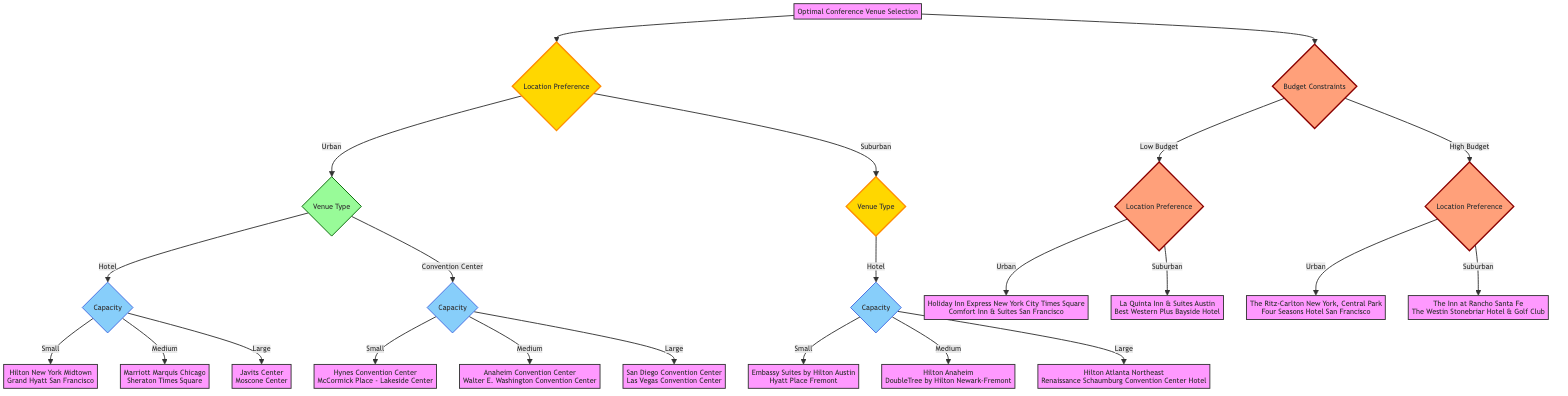What are the two possible categories for Location Preference? The diagram shows two main branches under the Location Preference node: Urban and Suburban.
Answer: Urban and Suburban Which venues are listed for a Small Hotel in an Urban location? The diagram points to the Hotel node under Urban and then specifies Small capacity, leading to the venues Hilton New York Midtown and Grand Hyatt San Francisco.
Answer: Hilton New York Midtown, Grand Hyatt San Francisco How many venues are available for Medium Capacity in Convention Centers? The diagram indicates a Medium capacity node under the Convention Center type, with two venues listed: Anaheim Convention Center and Walter E. Washington Convention Center, totaling two venues.
Answer: 2 If an attendee has a Low Budget, which two Urban venues can they select? The diagram branches from the Low Budget node to the Urban location, which lists Holiday Inn Express New York City Times Square and Comfort Inn & Suites San Francisco as available venues.
Answer: Holiday Inn Express New York City Times Square, Comfort Inn & Suites San Francisco What is the next criterion after selecting Suburban for Low Budget? Following the selection of Suburban under the Low Budget, the next criterion is Location Preference, which then branches to different venues based on the Low Budget selection.
Answer: Venue Preference Which type of venue has the highest capacity options listed? By examining the diagram, the Convention Center type offers venues categorized as Small (<150 attendees), Medium (150-500 attendees), and Large (>500 attendees), indicating it has three capacity options, which is more than the Hotel type.
Answer: Convention Center Which two venues are suitable for a High Budget in Suburban areas? The High Budget node leads to Suburban, which lists The Inn at Rancho Santa Fe and The Westin Stonebriar Hotel & Golf Club as suitable venues.
Answer: The Inn at Rancho Santa Fe, The Westin Stonebriar Hotel & Golf Club In total, how many distinct options for venue type are available in Urban locations? The diagram under Urban shows two types of venues: Hotel and Convention Center, leading to a total of two distinct options.
Answer: 2 What is the last node in the path if the criteria are Urban, Hotel, and Medium capacity? Starting from Urban, the flow goes to Hotel and then to Medium capacity, leading to the last venues listed, which are Marriott Marquis Chicago and Sheraton Times Square.
Answer: Marriott Marquis Chicago, Sheraton Times Square 